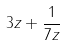<formula> <loc_0><loc_0><loc_500><loc_500>3 z + \frac { 1 } { 7 z }</formula> 